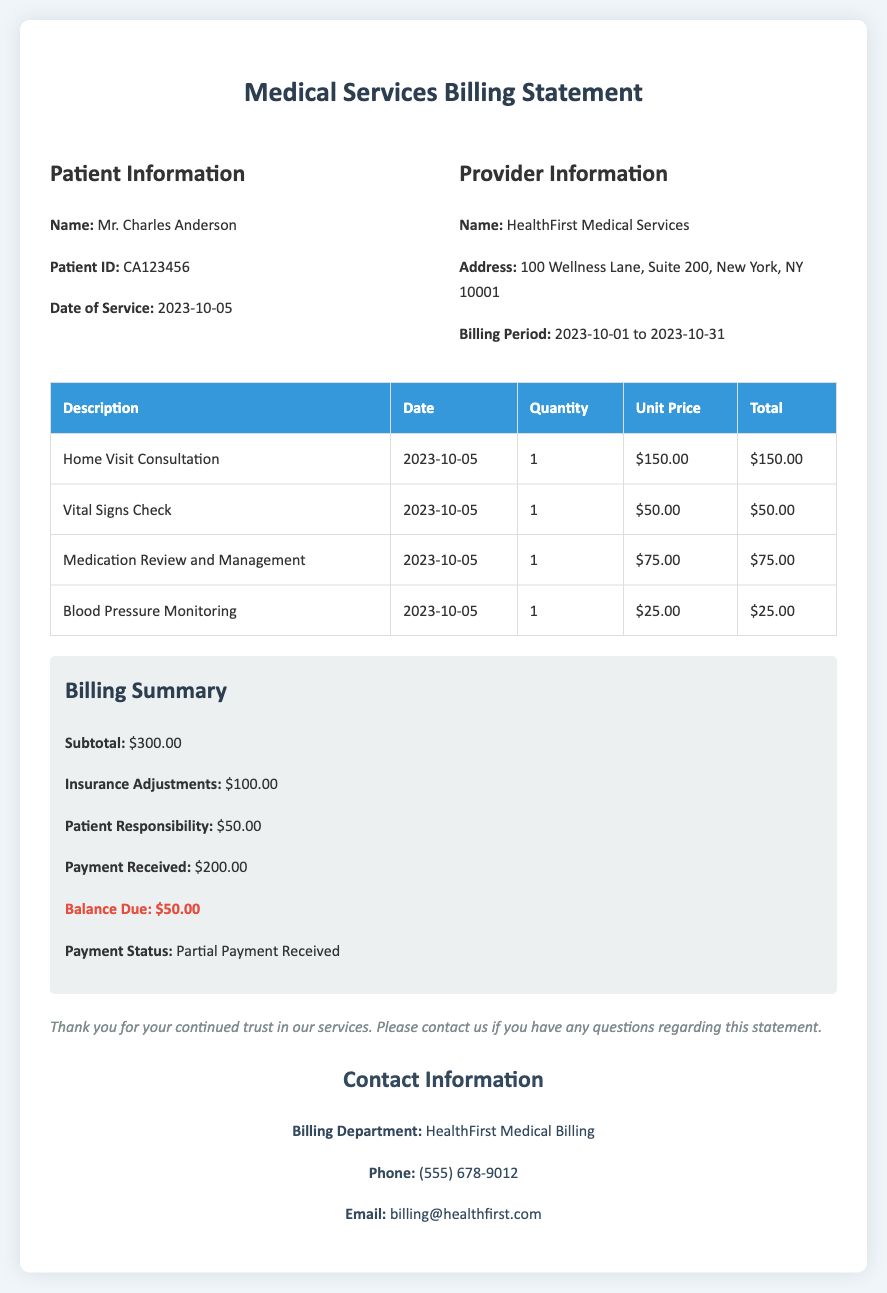What is the patient's name? The patient's name is listed in the patient information section of the document as Mr. Charles Anderson.
Answer: Mr. Charles Anderson What is the date of service? The date of service is specified under patient information and indicates when the medical services were rendered.
Answer: 2023-10-05 What is the total amount charged for the home visit consultation? The total charged for the home visit consultation can be found in the itemized charges table under the description "Home Visit Consultation."
Answer: $150.00 What is the subtotal amount for the services rendered? The subtotal amount is the total of all itemized charges before any adjustments or payments.
Answer: $300.00 What adjustments were made by the insurance? The insurance adjustments are noted in the billing summary, reflecting any reductions made to the total charges.
Answer: $100.00 How much is the balance due? The balance due is summarized in the billing summary section and represents the amount still owed after payments and adjustments.
Answer: $50.00 What is the payment status? The payment status indicates whether full payment has been received or if there are outstanding amounts, detailed in the billing summary.
Answer: Partial Payment Received What is the contact email for the billing department? The contact email is provided in the contact information section for any inquiries regarding the billing statement.
Answer: billing@healthfirst.com How many services were included in the billing statement? The number of services can be calculated by counting the distinct descriptions listed in the itemized charges table.
Answer: 4 